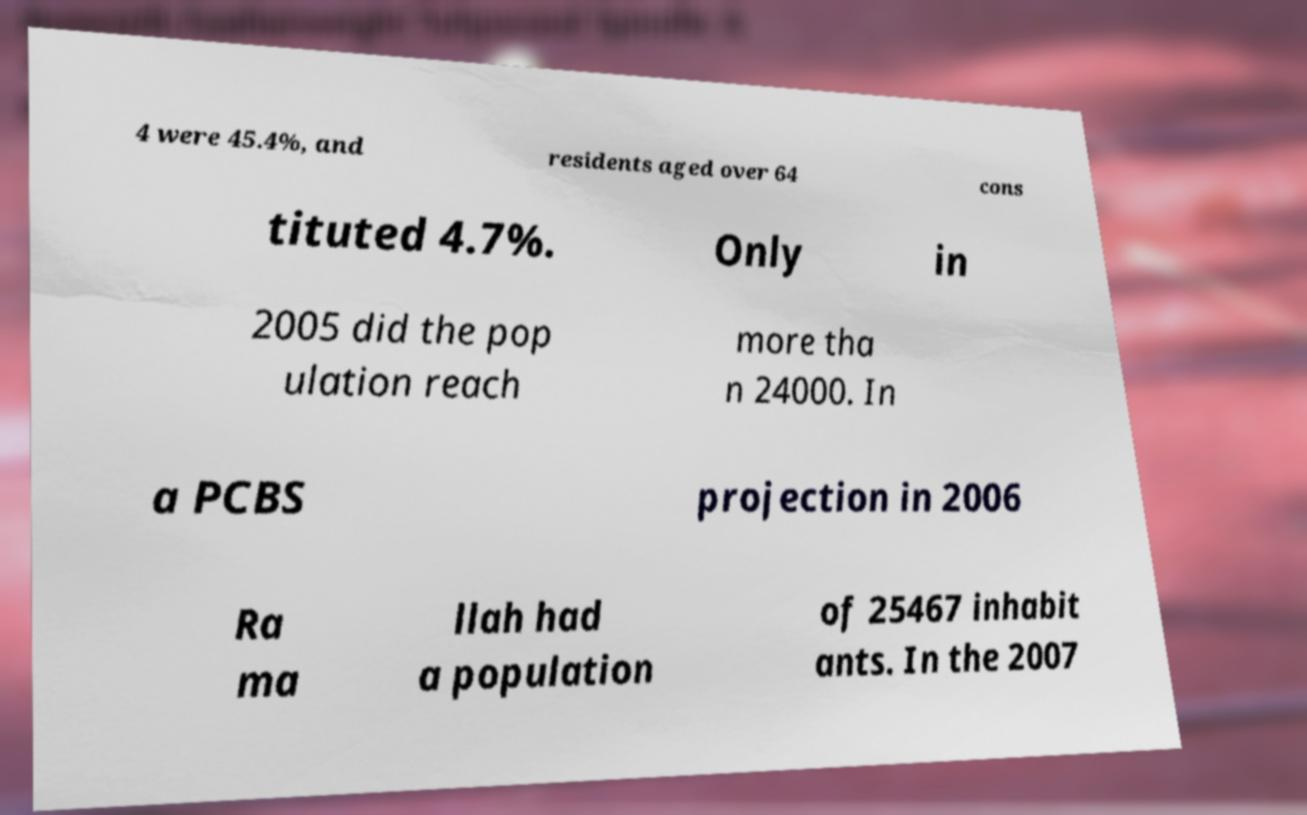Please read and relay the text visible in this image. What does it say? 4 were 45.4%, and residents aged over 64 cons tituted 4.7%. Only in 2005 did the pop ulation reach more tha n 24000. In a PCBS projection in 2006 Ra ma llah had a population of 25467 inhabit ants. In the 2007 